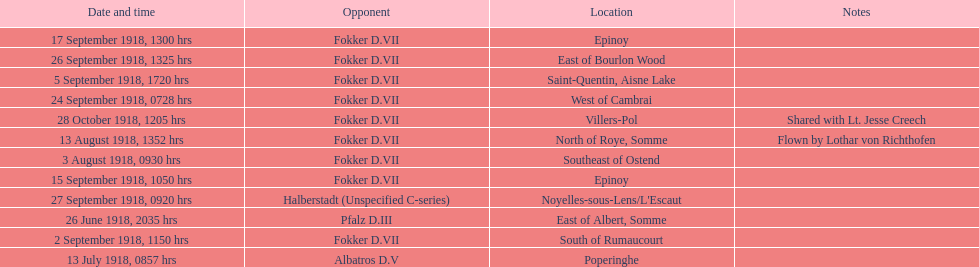Which opponent did kindley have the most victories against? Fokker D.VII. 